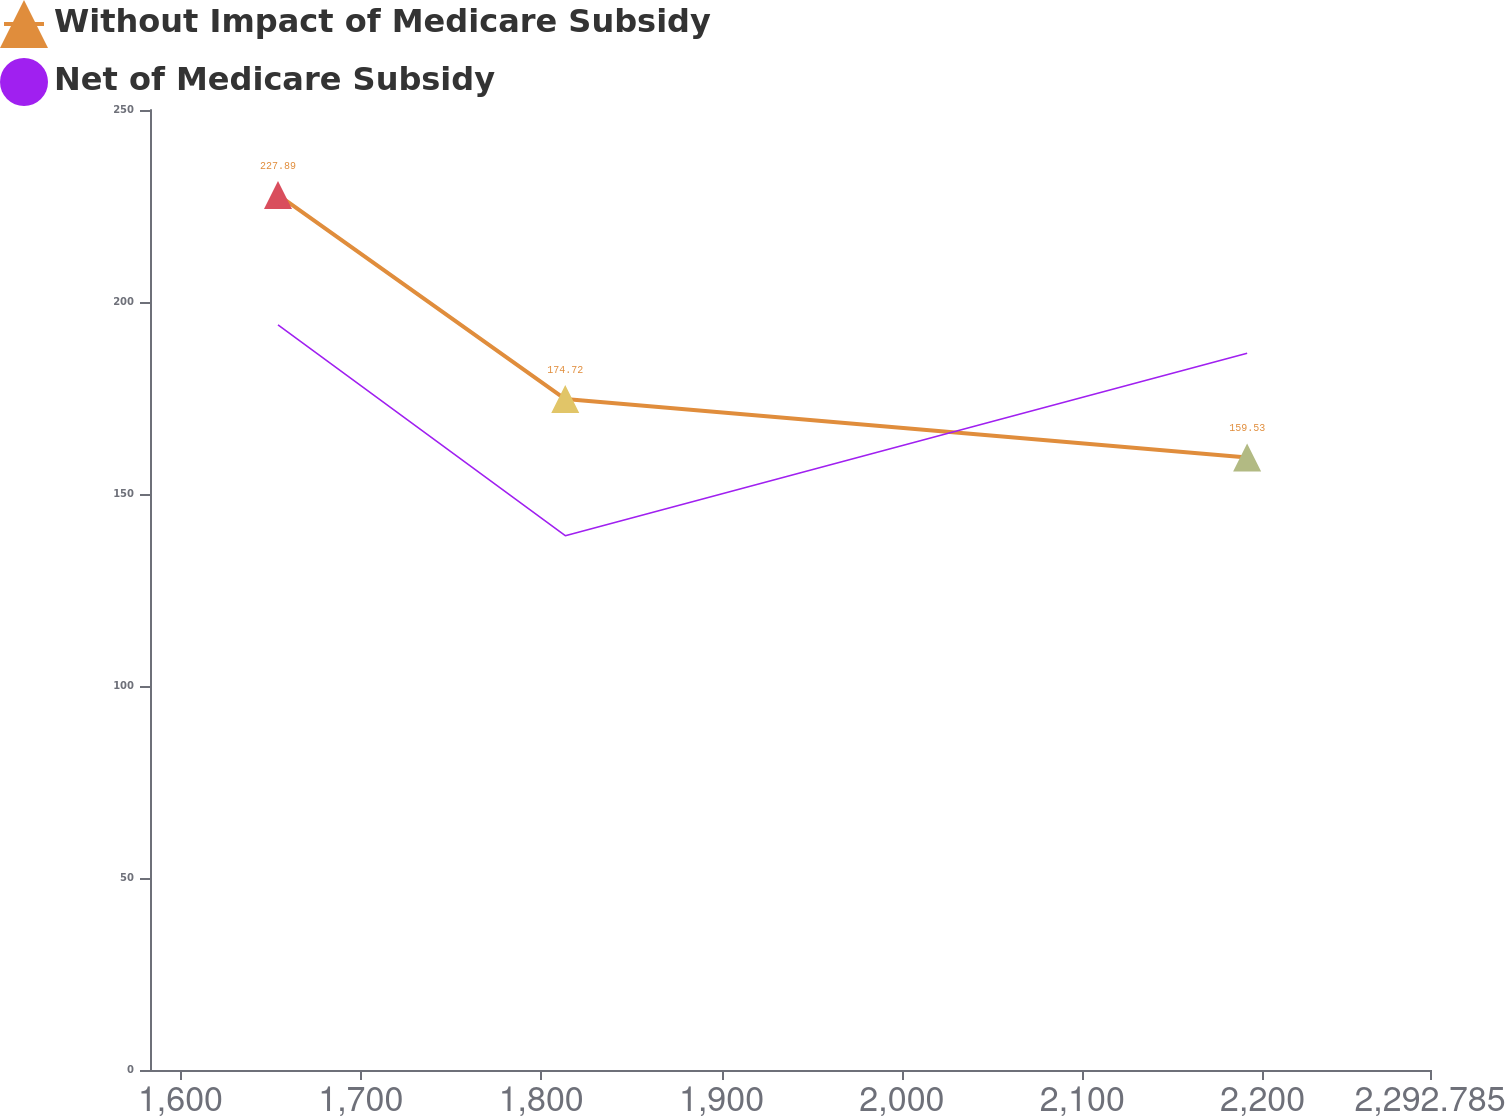Convert chart to OTSL. <chart><loc_0><loc_0><loc_500><loc_500><line_chart><ecel><fcel>Without Impact of Medicare Subsidy<fcel>Net of Medicare Subsidy<nl><fcel>1654.1<fcel>227.89<fcel>194.07<nl><fcel>1813.37<fcel>174.72<fcel>139.14<nl><fcel>2191.41<fcel>159.53<fcel>186.64<nl><fcel>2298.31<fcel>167.12<fcel>127.6<nl><fcel>2363.75<fcel>151.94<fcel>167.53<nl></chart> 